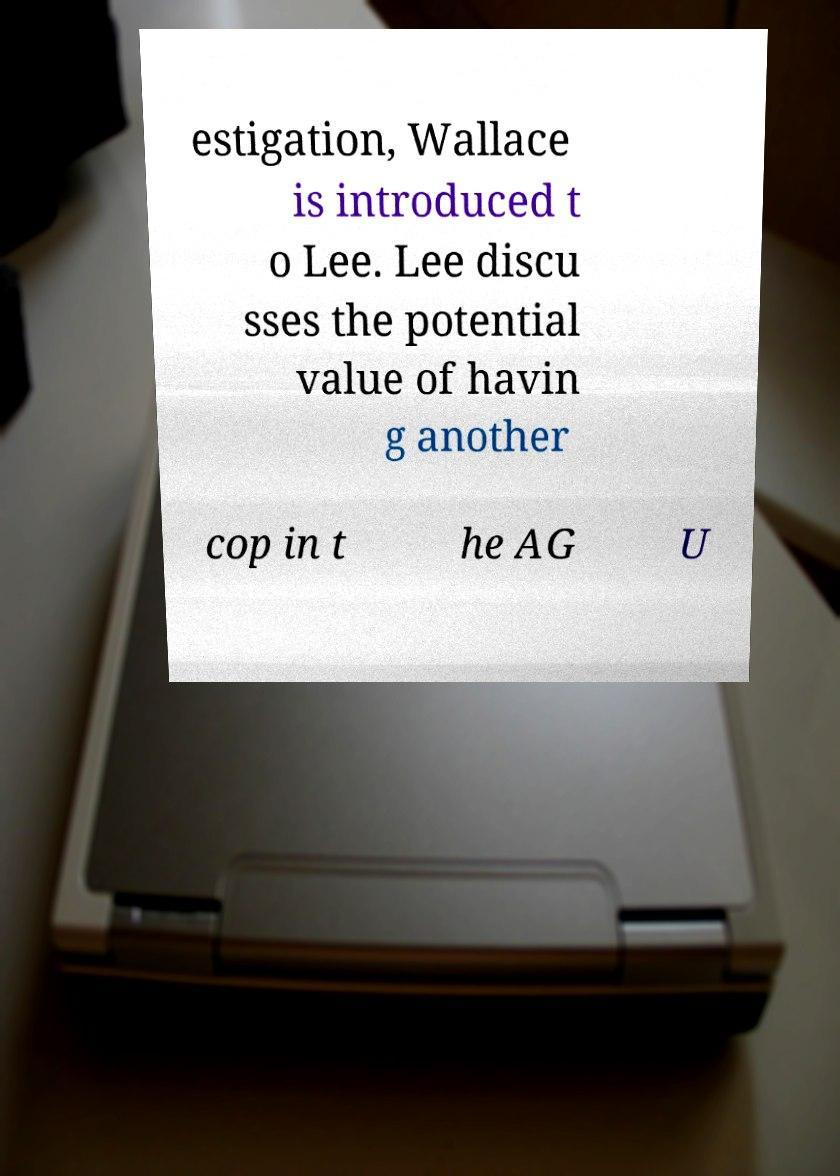There's text embedded in this image that I need extracted. Can you transcribe it verbatim? estigation, Wallace is introduced t o Lee. Lee discu sses the potential value of havin g another cop in t he AG U 